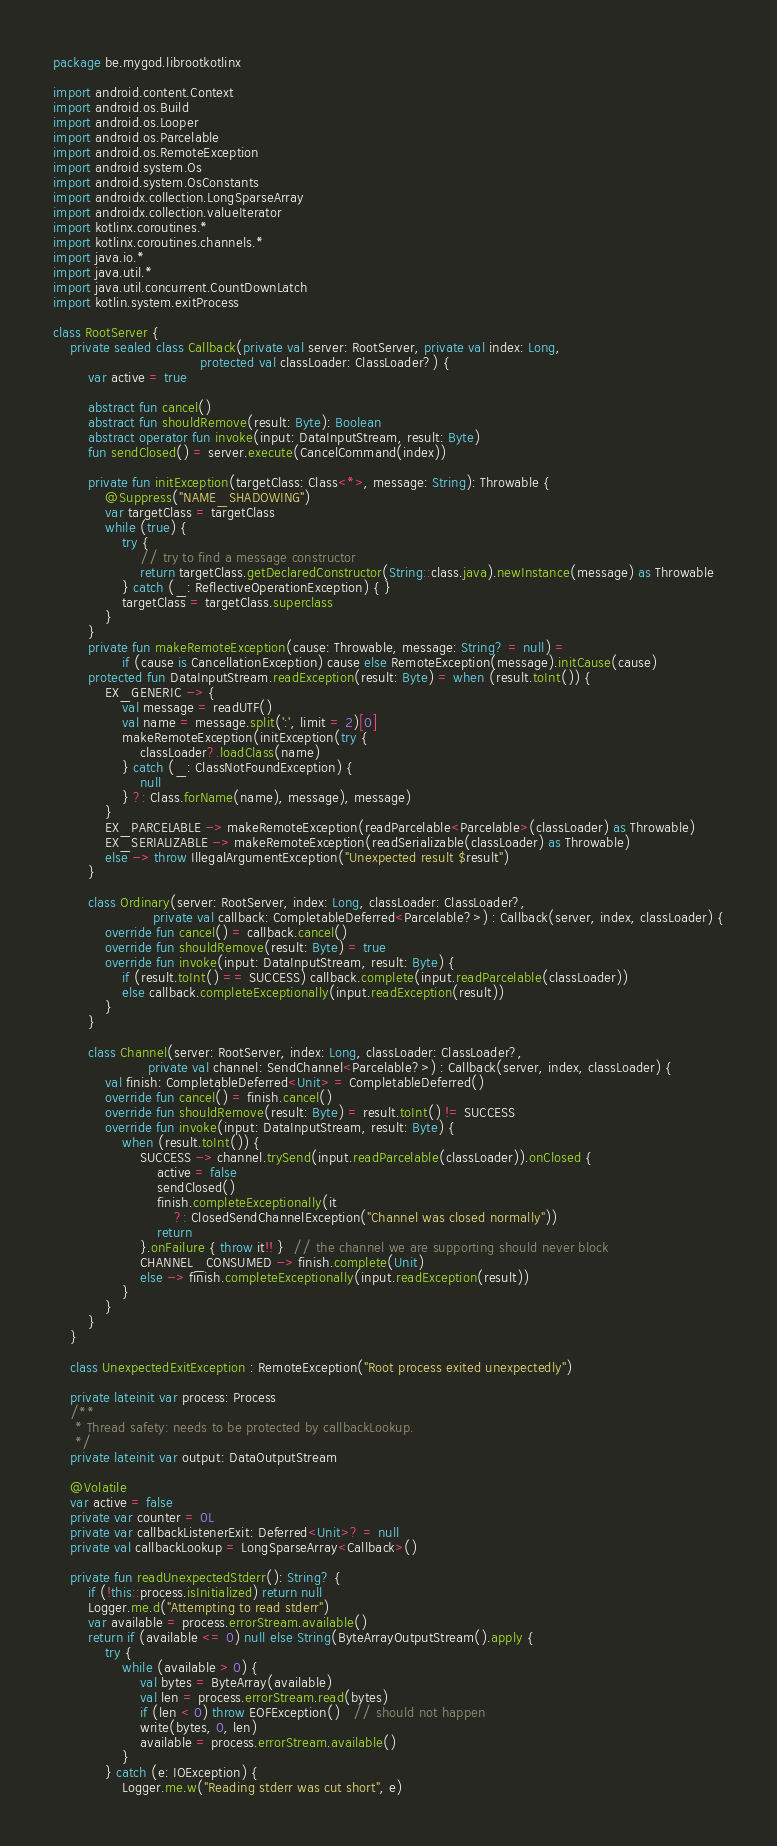Convert code to text. <code><loc_0><loc_0><loc_500><loc_500><_Kotlin_>package be.mygod.librootkotlinx

import android.content.Context
import android.os.Build
import android.os.Looper
import android.os.Parcelable
import android.os.RemoteException
import android.system.Os
import android.system.OsConstants
import androidx.collection.LongSparseArray
import androidx.collection.valueIterator
import kotlinx.coroutines.*
import kotlinx.coroutines.channels.*
import java.io.*
import java.util.*
import java.util.concurrent.CountDownLatch
import kotlin.system.exitProcess

class RootServer {
    private sealed class Callback(private val server: RootServer, private val index: Long,
                                  protected val classLoader: ClassLoader?) {
        var active = true

        abstract fun cancel()
        abstract fun shouldRemove(result: Byte): Boolean
        abstract operator fun invoke(input: DataInputStream, result: Byte)
        fun sendClosed() = server.execute(CancelCommand(index))

        private fun initException(targetClass: Class<*>, message: String): Throwable {
            @Suppress("NAME_SHADOWING")
            var targetClass = targetClass
            while (true) {
                try {
                    // try to find a message constructor
                    return targetClass.getDeclaredConstructor(String::class.java).newInstance(message) as Throwable
                } catch (_: ReflectiveOperationException) { }
                targetClass = targetClass.superclass
            }
        }
        private fun makeRemoteException(cause: Throwable, message: String? = null) =
                if (cause is CancellationException) cause else RemoteException(message).initCause(cause)
        protected fun DataInputStream.readException(result: Byte) = when (result.toInt()) {
            EX_GENERIC -> {
                val message = readUTF()
                val name = message.split(':', limit = 2)[0]
                makeRemoteException(initException(try {
                    classLoader?.loadClass(name)
                } catch (_: ClassNotFoundException) {
                    null
                } ?: Class.forName(name), message), message)
            }
            EX_PARCELABLE -> makeRemoteException(readParcelable<Parcelable>(classLoader) as Throwable)
            EX_SERIALIZABLE -> makeRemoteException(readSerializable(classLoader) as Throwable)
            else -> throw IllegalArgumentException("Unexpected result $result")
        }

        class Ordinary(server: RootServer, index: Long, classLoader: ClassLoader?,
                       private val callback: CompletableDeferred<Parcelable?>) : Callback(server, index, classLoader) {
            override fun cancel() = callback.cancel()
            override fun shouldRemove(result: Byte) = true
            override fun invoke(input: DataInputStream, result: Byte) {
                if (result.toInt() == SUCCESS) callback.complete(input.readParcelable(classLoader))
                else callback.completeExceptionally(input.readException(result))
            }
        }

        class Channel(server: RootServer, index: Long, classLoader: ClassLoader?,
                      private val channel: SendChannel<Parcelable?>) : Callback(server, index, classLoader) {
            val finish: CompletableDeferred<Unit> = CompletableDeferred()
            override fun cancel() = finish.cancel()
            override fun shouldRemove(result: Byte) = result.toInt() != SUCCESS
            override fun invoke(input: DataInputStream, result: Byte) {
                when (result.toInt()) {
                    SUCCESS -> channel.trySend(input.readParcelable(classLoader)).onClosed {
                        active = false
                        sendClosed()
                        finish.completeExceptionally(it
                            ?: ClosedSendChannelException("Channel was closed normally"))
                        return
                    }.onFailure { throw it!! }  // the channel we are supporting should never block
                    CHANNEL_CONSUMED -> finish.complete(Unit)
                    else -> finish.completeExceptionally(input.readException(result))
                }
            }
        }
    }

    class UnexpectedExitException : RemoteException("Root process exited unexpectedly")

    private lateinit var process: Process
    /**
     * Thread safety: needs to be protected by callbackLookup.
     */
    private lateinit var output: DataOutputStream

    @Volatile
    var active = false
    private var counter = 0L
    private var callbackListenerExit: Deferred<Unit>? = null
    private val callbackLookup = LongSparseArray<Callback>()

    private fun readUnexpectedStderr(): String? {
        if (!this::process.isInitialized) return null
        Logger.me.d("Attempting to read stderr")
        var available = process.errorStream.available()
        return if (available <= 0) null else String(ByteArrayOutputStream().apply {
            try {
                while (available > 0) {
                    val bytes = ByteArray(available)
                    val len = process.errorStream.read(bytes)
                    if (len < 0) throw EOFException()   // should not happen
                    write(bytes, 0, len)
                    available = process.errorStream.available()
                }
            } catch (e: IOException) {
                Logger.me.w("Reading stderr was cut short", e)</code> 